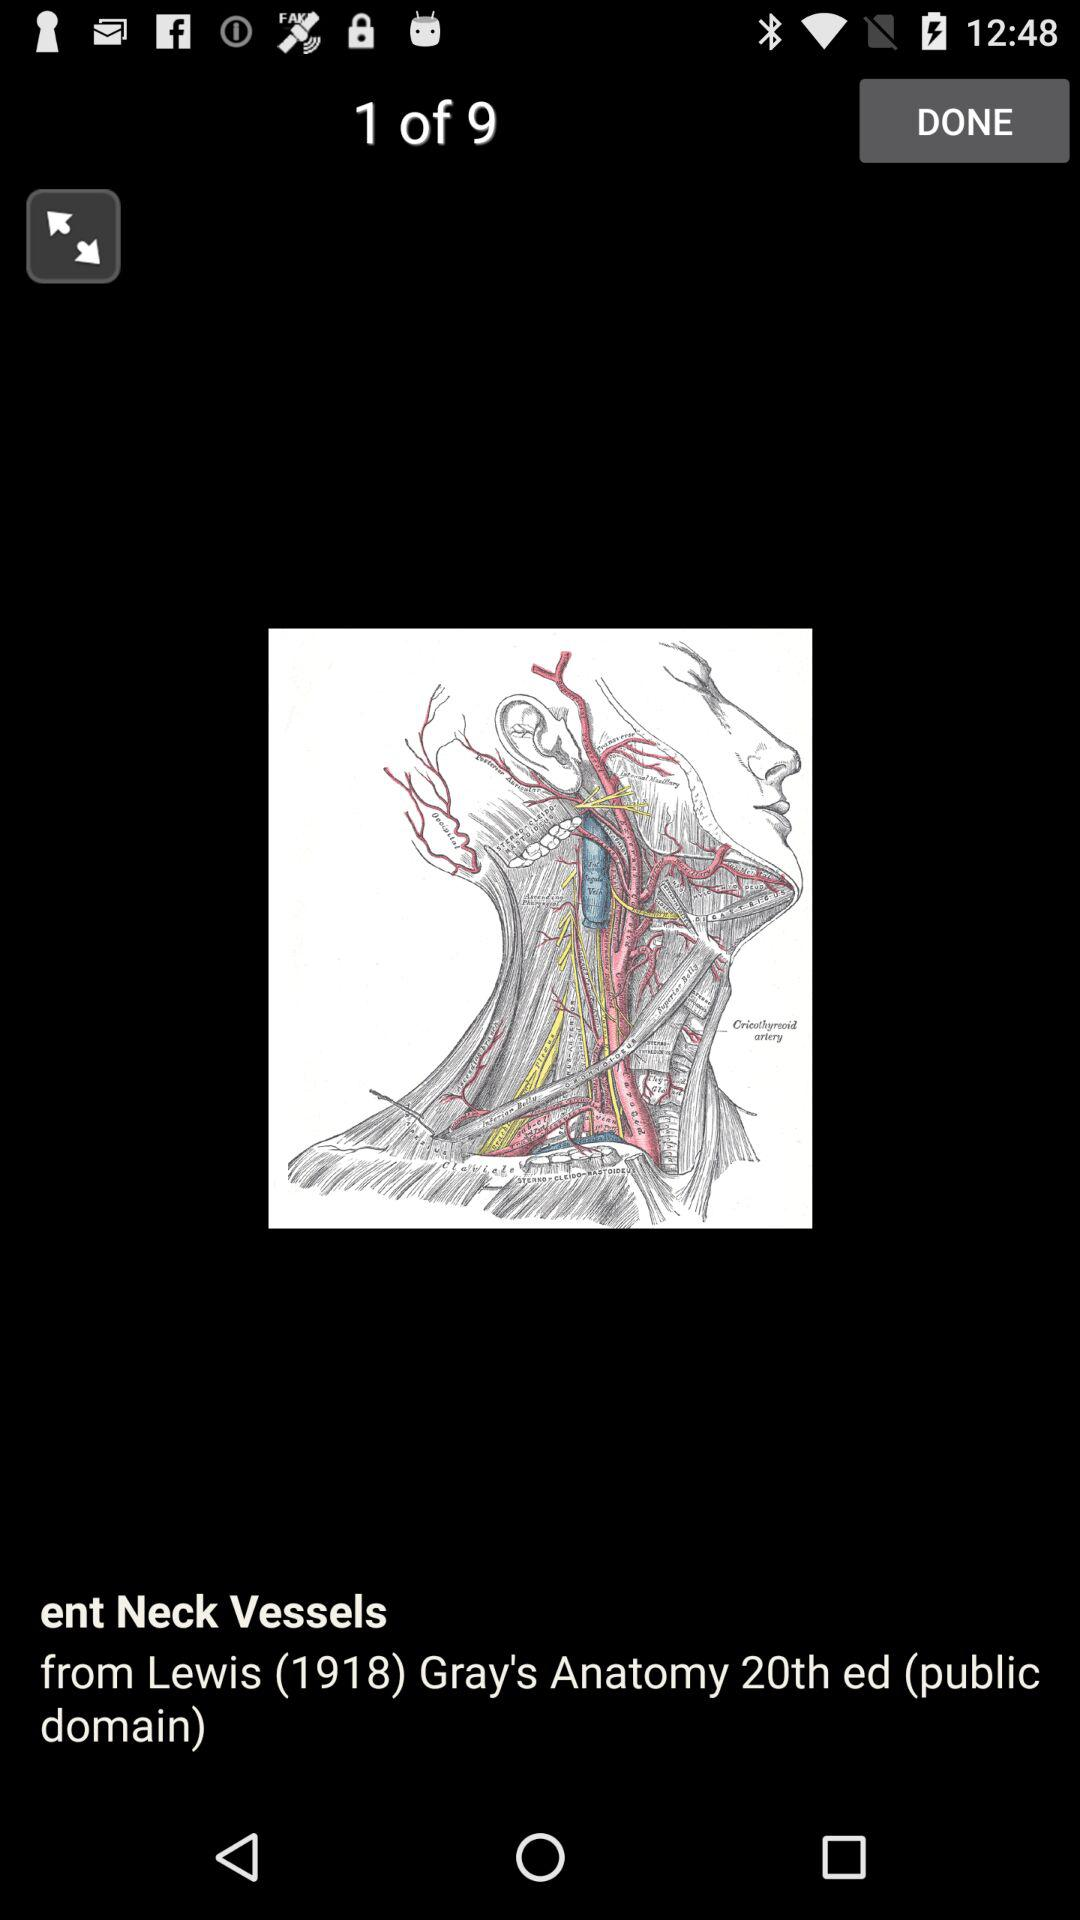What is the edition? It is the 20th edition. 